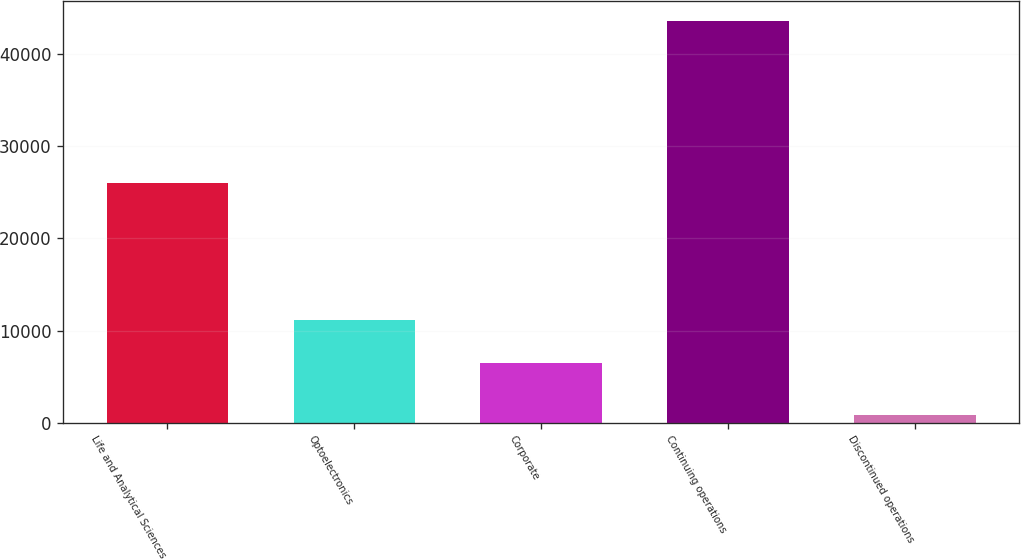Convert chart to OTSL. <chart><loc_0><loc_0><loc_500><loc_500><bar_chart><fcel>Life and Analytical Sciences<fcel>Optoelectronics<fcel>Corporate<fcel>Continuing operations<fcel>Discontinued operations<nl><fcel>25973<fcel>11122<fcel>6497<fcel>43592<fcel>881<nl></chart> 